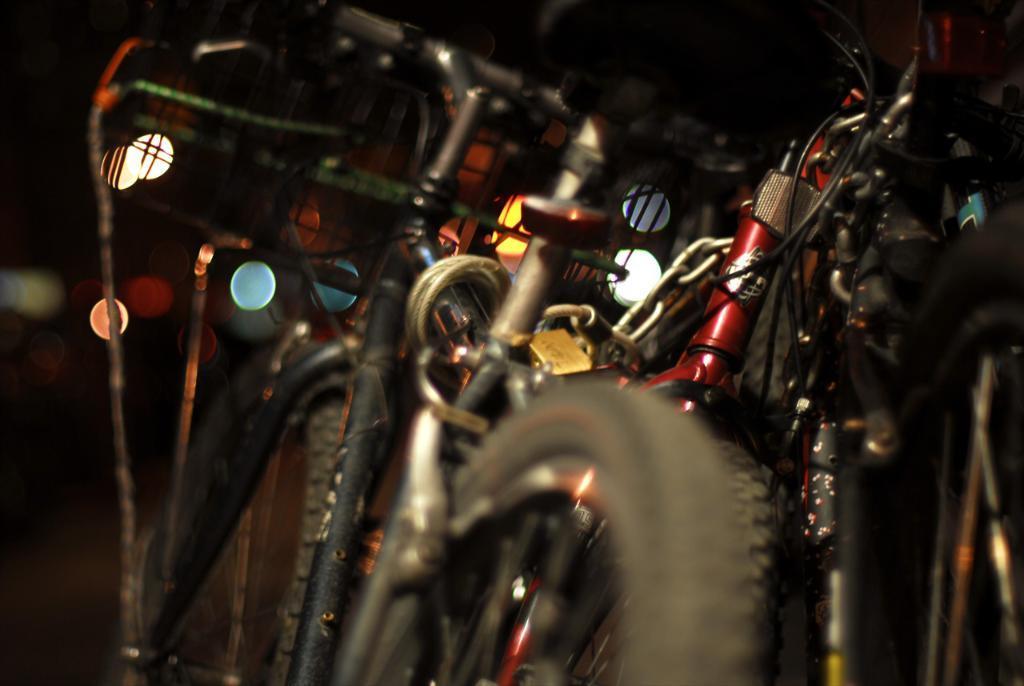How would you summarize this image in a sentence or two? The picture consists of bicycles. The background is blurred. 